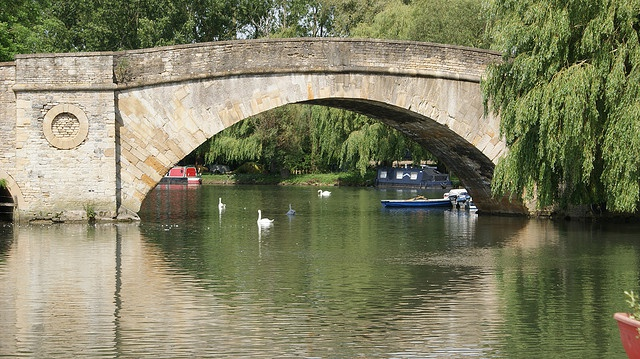Describe the objects in this image and their specific colors. I can see potted plant in darkgreen, brown, tan, and olive tones, boat in darkgreen, gray, black, navy, and darkblue tones, boat in darkgreen, black, navy, blue, and lightgray tones, boat in darkgreen, gray, salmon, white, and lightpink tones, and bird in darkgreen, white, darkgray, and gray tones in this image. 